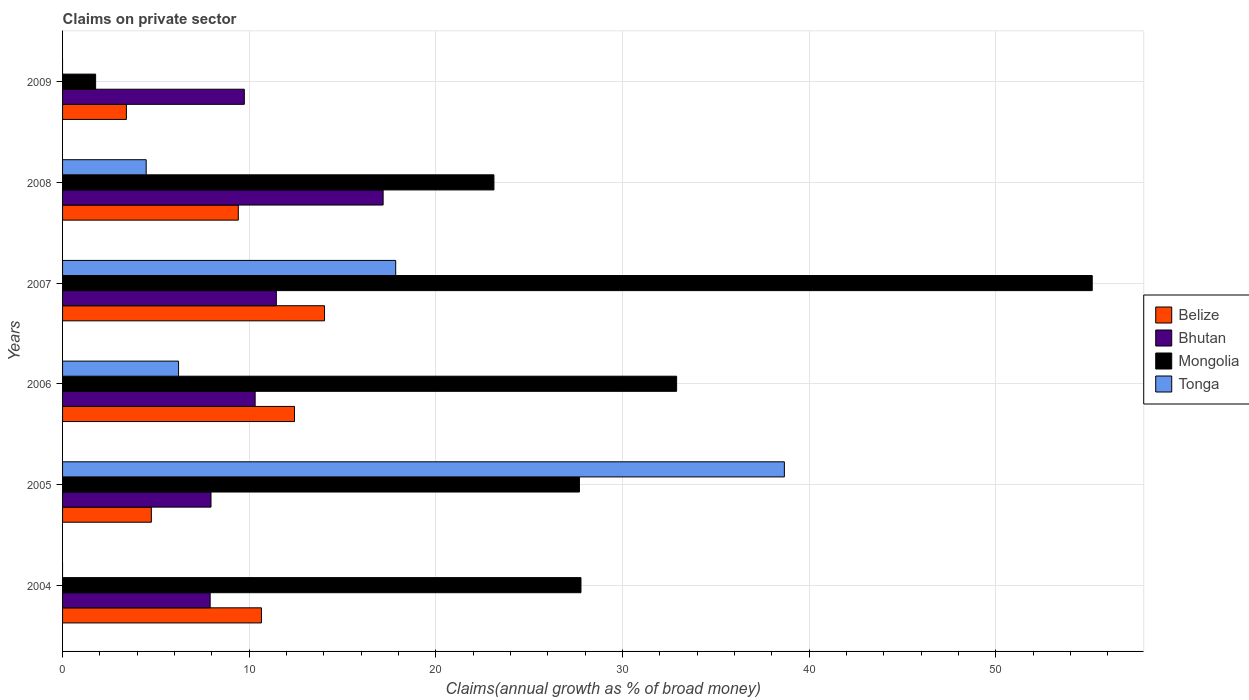How many groups of bars are there?
Offer a terse response. 6. Are the number of bars per tick equal to the number of legend labels?
Provide a short and direct response. No. Are the number of bars on each tick of the Y-axis equal?
Your answer should be compact. No. How many bars are there on the 6th tick from the top?
Your answer should be compact. 3. What is the percentage of broad money claimed on private sector in Tonga in 2008?
Offer a very short reply. 4.48. Across all years, what is the maximum percentage of broad money claimed on private sector in Belize?
Give a very brief answer. 14.04. Across all years, what is the minimum percentage of broad money claimed on private sector in Mongolia?
Make the answer very short. 1.77. In which year was the percentage of broad money claimed on private sector in Bhutan maximum?
Provide a succinct answer. 2008. What is the total percentage of broad money claimed on private sector in Tonga in the graph?
Your answer should be compact. 67.22. What is the difference between the percentage of broad money claimed on private sector in Belize in 2005 and that in 2009?
Make the answer very short. 1.34. What is the difference between the percentage of broad money claimed on private sector in Bhutan in 2009 and the percentage of broad money claimed on private sector in Tonga in 2007?
Give a very brief answer. -8.11. What is the average percentage of broad money claimed on private sector in Belize per year?
Your answer should be very brief. 9.12. In the year 2005, what is the difference between the percentage of broad money claimed on private sector in Mongolia and percentage of broad money claimed on private sector in Bhutan?
Keep it short and to the point. 19.74. What is the ratio of the percentage of broad money claimed on private sector in Bhutan in 2007 to that in 2008?
Your answer should be compact. 0.67. What is the difference between the highest and the second highest percentage of broad money claimed on private sector in Belize?
Your answer should be compact. 1.61. What is the difference between the highest and the lowest percentage of broad money claimed on private sector in Mongolia?
Provide a succinct answer. 53.4. Is the sum of the percentage of broad money claimed on private sector in Mongolia in 2006 and 2009 greater than the maximum percentage of broad money claimed on private sector in Belize across all years?
Offer a terse response. Yes. Are all the bars in the graph horizontal?
Your answer should be compact. Yes. What is the difference between two consecutive major ticks on the X-axis?
Ensure brevity in your answer.  10. Does the graph contain any zero values?
Your answer should be very brief. Yes. Does the graph contain grids?
Ensure brevity in your answer.  Yes. Where does the legend appear in the graph?
Offer a terse response. Center right. How many legend labels are there?
Your answer should be compact. 4. What is the title of the graph?
Your answer should be compact. Claims on private sector. What is the label or title of the X-axis?
Your answer should be very brief. Claims(annual growth as % of broad money). What is the label or title of the Y-axis?
Offer a terse response. Years. What is the Claims(annual growth as % of broad money) in Belize in 2004?
Keep it short and to the point. 10.66. What is the Claims(annual growth as % of broad money) in Bhutan in 2004?
Ensure brevity in your answer.  7.91. What is the Claims(annual growth as % of broad money) of Mongolia in 2004?
Provide a short and direct response. 27.78. What is the Claims(annual growth as % of broad money) of Belize in 2005?
Provide a short and direct response. 4.76. What is the Claims(annual growth as % of broad money) of Bhutan in 2005?
Offer a terse response. 7.95. What is the Claims(annual growth as % of broad money) in Mongolia in 2005?
Provide a succinct answer. 27.69. What is the Claims(annual growth as % of broad money) in Tonga in 2005?
Your answer should be very brief. 38.67. What is the Claims(annual growth as % of broad money) in Belize in 2006?
Your response must be concise. 12.43. What is the Claims(annual growth as % of broad money) of Bhutan in 2006?
Offer a terse response. 10.32. What is the Claims(annual growth as % of broad money) in Mongolia in 2006?
Your answer should be very brief. 32.9. What is the Claims(annual growth as % of broad money) in Tonga in 2006?
Offer a terse response. 6.22. What is the Claims(annual growth as % of broad money) of Belize in 2007?
Make the answer very short. 14.04. What is the Claims(annual growth as % of broad money) of Bhutan in 2007?
Ensure brevity in your answer.  11.45. What is the Claims(annual growth as % of broad money) of Mongolia in 2007?
Offer a very short reply. 55.17. What is the Claims(annual growth as % of broad money) of Tonga in 2007?
Offer a terse response. 17.85. What is the Claims(annual growth as % of broad money) of Belize in 2008?
Your answer should be very brief. 9.42. What is the Claims(annual growth as % of broad money) in Bhutan in 2008?
Give a very brief answer. 17.18. What is the Claims(annual growth as % of broad money) of Mongolia in 2008?
Make the answer very short. 23.11. What is the Claims(annual growth as % of broad money) in Tonga in 2008?
Your answer should be compact. 4.48. What is the Claims(annual growth as % of broad money) in Belize in 2009?
Provide a succinct answer. 3.42. What is the Claims(annual growth as % of broad money) of Bhutan in 2009?
Give a very brief answer. 9.74. What is the Claims(annual growth as % of broad money) of Mongolia in 2009?
Offer a terse response. 1.77. Across all years, what is the maximum Claims(annual growth as % of broad money) of Belize?
Ensure brevity in your answer.  14.04. Across all years, what is the maximum Claims(annual growth as % of broad money) of Bhutan?
Offer a terse response. 17.18. Across all years, what is the maximum Claims(annual growth as % of broad money) in Mongolia?
Provide a succinct answer. 55.17. Across all years, what is the maximum Claims(annual growth as % of broad money) of Tonga?
Your answer should be very brief. 38.67. Across all years, what is the minimum Claims(annual growth as % of broad money) in Belize?
Give a very brief answer. 3.42. Across all years, what is the minimum Claims(annual growth as % of broad money) in Bhutan?
Your answer should be very brief. 7.91. Across all years, what is the minimum Claims(annual growth as % of broad money) of Mongolia?
Your response must be concise. 1.77. Across all years, what is the minimum Claims(annual growth as % of broad money) of Tonga?
Give a very brief answer. 0. What is the total Claims(annual growth as % of broad money) of Belize in the graph?
Provide a short and direct response. 54.71. What is the total Claims(annual growth as % of broad money) of Bhutan in the graph?
Give a very brief answer. 64.55. What is the total Claims(annual growth as % of broad money) in Mongolia in the graph?
Provide a short and direct response. 168.43. What is the total Claims(annual growth as % of broad money) in Tonga in the graph?
Ensure brevity in your answer.  67.22. What is the difference between the Claims(annual growth as % of broad money) in Belize in 2004 and that in 2005?
Provide a short and direct response. 5.9. What is the difference between the Claims(annual growth as % of broad money) of Bhutan in 2004 and that in 2005?
Offer a very short reply. -0.05. What is the difference between the Claims(annual growth as % of broad money) of Mongolia in 2004 and that in 2005?
Give a very brief answer. 0.08. What is the difference between the Claims(annual growth as % of broad money) in Belize in 2004 and that in 2006?
Ensure brevity in your answer.  -1.77. What is the difference between the Claims(annual growth as % of broad money) in Bhutan in 2004 and that in 2006?
Your response must be concise. -2.41. What is the difference between the Claims(annual growth as % of broad money) in Mongolia in 2004 and that in 2006?
Make the answer very short. -5.13. What is the difference between the Claims(annual growth as % of broad money) of Belize in 2004 and that in 2007?
Your answer should be compact. -3.38. What is the difference between the Claims(annual growth as % of broad money) of Bhutan in 2004 and that in 2007?
Offer a very short reply. -3.55. What is the difference between the Claims(annual growth as % of broad money) in Mongolia in 2004 and that in 2007?
Give a very brief answer. -27.39. What is the difference between the Claims(annual growth as % of broad money) of Belize in 2004 and that in 2008?
Provide a succinct answer. 1.24. What is the difference between the Claims(annual growth as % of broad money) in Bhutan in 2004 and that in 2008?
Ensure brevity in your answer.  -9.27. What is the difference between the Claims(annual growth as % of broad money) of Mongolia in 2004 and that in 2008?
Keep it short and to the point. 4.66. What is the difference between the Claims(annual growth as % of broad money) in Belize in 2004 and that in 2009?
Provide a short and direct response. 7.24. What is the difference between the Claims(annual growth as % of broad money) in Bhutan in 2004 and that in 2009?
Your answer should be compact. -1.83. What is the difference between the Claims(annual growth as % of broad money) of Mongolia in 2004 and that in 2009?
Your answer should be very brief. 26. What is the difference between the Claims(annual growth as % of broad money) in Belize in 2005 and that in 2006?
Your response must be concise. -7.67. What is the difference between the Claims(annual growth as % of broad money) of Bhutan in 2005 and that in 2006?
Provide a succinct answer. -2.36. What is the difference between the Claims(annual growth as % of broad money) in Mongolia in 2005 and that in 2006?
Your response must be concise. -5.21. What is the difference between the Claims(annual growth as % of broad money) in Tonga in 2005 and that in 2006?
Ensure brevity in your answer.  32.46. What is the difference between the Claims(annual growth as % of broad money) of Belize in 2005 and that in 2007?
Ensure brevity in your answer.  -9.28. What is the difference between the Claims(annual growth as % of broad money) in Bhutan in 2005 and that in 2007?
Provide a succinct answer. -3.5. What is the difference between the Claims(annual growth as % of broad money) of Mongolia in 2005 and that in 2007?
Your response must be concise. -27.48. What is the difference between the Claims(annual growth as % of broad money) of Tonga in 2005 and that in 2007?
Ensure brevity in your answer.  20.83. What is the difference between the Claims(annual growth as % of broad money) of Belize in 2005 and that in 2008?
Offer a terse response. -4.66. What is the difference between the Claims(annual growth as % of broad money) of Bhutan in 2005 and that in 2008?
Make the answer very short. -9.22. What is the difference between the Claims(annual growth as % of broad money) in Mongolia in 2005 and that in 2008?
Provide a short and direct response. 4.58. What is the difference between the Claims(annual growth as % of broad money) of Tonga in 2005 and that in 2008?
Offer a terse response. 34.19. What is the difference between the Claims(annual growth as % of broad money) of Belize in 2005 and that in 2009?
Offer a terse response. 1.34. What is the difference between the Claims(annual growth as % of broad money) of Bhutan in 2005 and that in 2009?
Provide a short and direct response. -1.78. What is the difference between the Claims(annual growth as % of broad money) in Mongolia in 2005 and that in 2009?
Your answer should be very brief. 25.92. What is the difference between the Claims(annual growth as % of broad money) of Belize in 2006 and that in 2007?
Provide a short and direct response. -1.61. What is the difference between the Claims(annual growth as % of broad money) in Bhutan in 2006 and that in 2007?
Ensure brevity in your answer.  -1.14. What is the difference between the Claims(annual growth as % of broad money) in Mongolia in 2006 and that in 2007?
Ensure brevity in your answer.  -22.27. What is the difference between the Claims(annual growth as % of broad money) in Tonga in 2006 and that in 2007?
Offer a very short reply. -11.63. What is the difference between the Claims(annual growth as % of broad money) in Belize in 2006 and that in 2008?
Your response must be concise. 3.01. What is the difference between the Claims(annual growth as % of broad money) in Bhutan in 2006 and that in 2008?
Your answer should be very brief. -6.86. What is the difference between the Claims(annual growth as % of broad money) in Mongolia in 2006 and that in 2008?
Keep it short and to the point. 9.79. What is the difference between the Claims(annual growth as % of broad money) in Tonga in 2006 and that in 2008?
Provide a succinct answer. 1.73. What is the difference between the Claims(annual growth as % of broad money) of Belize in 2006 and that in 2009?
Your response must be concise. 9.01. What is the difference between the Claims(annual growth as % of broad money) of Bhutan in 2006 and that in 2009?
Provide a succinct answer. 0.58. What is the difference between the Claims(annual growth as % of broad money) of Mongolia in 2006 and that in 2009?
Provide a succinct answer. 31.13. What is the difference between the Claims(annual growth as % of broad money) of Belize in 2007 and that in 2008?
Your response must be concise. 4.62. What is the difference between the Claims(annual growth as % of broad money) in Bhutan in 2007 and that in 2008?
Ensure brevity in your answer.  -5.72. What is the difference between the Claims(annual growth as % of broad money) in Mongolia in 2007 and that in 2008?
Give a very brief answer. 32.06. What is the difference between the Claims(annual growth as % of broad money) in Tonga in 2007 and that in 2008?
Your response must be concise. 13.37. What is the difference between the Claims(annual growth as % of broad money) of Belize in 2007 and that in 2009?
Provide a short and direct response. 10.62. What is the difference between the Claims(annual growth as % of broad money) in Bhutan in 2007 and that in 2009?
Your response must be concise. 1.72. What is the difference between the Claims(annual growth as % of broad money) of Mongolia in 2007 and that in 2009?
Ensure brevity in your answer.  53.4. What is the difference between the Claims(annual growth as % of broad money) of Belize in 2008 and that in 2009?
Your answer should be compact. 6. What is the difference between the Claims(annual growth as % of broad money) of Bhutan in 2008 and that in 2009?
Offer a terse response. 7.44. What is the difference between the Claims(annual growth as % of broad money) of Mongolia in 2008 and that in 2009?
Your response must be concise. 21.34. What is the difference between the Claims(annual growth as % of broad money) of Belize in 2004 and the Claims(annual growth as % of broad money) of Bhutan in 2005?
Ensure brevity in your answer.  2.7. What is the difference between the Claims(annual growth as % of broad money) in Belize in 2004 and the Claims(annual growth as % of broad money) in Mongolia in 2005?
Keep it short and to the point. -17.04. What is the difference between the Claims(annual growth as % of broad money) in Belize in 2004 and the Claims(annual growth as % of broad money) in Tonga in 2005?
Ensure brevity in your answer.  -28.02. What is the difference between the Claims(annual growth as % of broad money) in Bhutan in 2004 and the Claims(annual growth as % of broad money) in Mongolia in 2005?
Offer a terse response. -19.79. What is the difference between the Claims(annual growth as % of broad money) of Bhutan in 2004 and the Claims(annual growth as % of broad money) of Tonga in 2005?
Provide a short and direct response. -30.77. What is the difference between the Claims(annual growth as % of broad money) of Mongolia in 2004 and the Claims(annual growth as % of broad money) of Tonga in 2005?
Provide a succinct answer. -10.9. What is the difference between the Claims(annual growth as % of broad money) of Belize in 2004 and the Claims(annual growth as % of broad money) of Bhutan in 2006?
Your response must be concise. 0.34. What is the difference between the Claims(annual growth as % of broad money) in Belize in 2004 and the Claims(annual growth as % of broad money) in Mongolia in 2006?
Offer a very short reply. -22.25. What is the difference between the Claims(annual growth as % of broad money) of Belize in 2004 and the Claims(annual growth as % of broad money) of Tonga in 2006?
Give a very brief answer. 4.44. What is the difference between the Claims(annual growth as % of broad money) in Bhutan in 2004 and the Claims(annual growth as % of broad money) in Mongolia in 2006?
Make the answer very short. -24.99. What is the difference between the Claims(annual growth as % of broad money) in Bhutan in 2004 and the Claims(annual growth as % of broad money) in Tonga in 2006?
Make the answer very short. 1.69. What is the difference between the Claims(annual growth as % of broad money) of Mongolia in 2004 and the Claims(annual growth as % of broad money) of Tonga in 2006?
Provide a succinct answer. 21.56. What is the difference between the Claims(annual growth as % of broad money) of Belize in 2004 and the Claims(annual growth as % of broad money) of Bhutan in 2007?
Make the answer very short. -0.8. What is the difference between the Claims(annual growth as % of broad money) in Belize in 2004 and the Claims(annual growth as % of broad money) in Mongolia in 2007?
Offer a very short reply. -44.51. What is the difference between the Claims(annual growth as % of broad money) of Belize in 2004 and the Claims(annual growth as % of broad money) of Tonga in 2007?
Provide a succinct answer. -7.19. What is the difference between the Claims(annual growth as % of broad money) in Bhutan in 2004 and the Claims(annual growth as % of broad money) in Mongolia in 2007?
Keep it short and to the point. -47.26. What is the difference between the Claims(annual growth as % of broad money) in Bhutan in 2004 and the Claims(annual growth as % of broad money) in Tonga in 2007?
Ensure brevity in your answer.  -9.94. What is the difference between the Claims(annual growth as % of broad money) in Mongolia in 2004 and the Claims(annual growth as % of broad money) in Tonga in 2007?
Your response must be concise. 9.93. What is the difference between the Claims(annual growth as % of broad money) in Belize in 2004 and the Claims(annual growth as % of broad money) in Bhutan in 2008?
Provide a short and direct response. -6.52. What is the difference between the Claims(annual growth as % of broad money) in Belize in 2004 and the Claims(annual growth as % of broad money) in Mongolia in 2008?
Make the answer very short. -12.46. What is the difference between the Claims(annual growth as % of broad money) in Belize in 2004 and the Claims(annual growth as % of broad money) in Tonga in 2008?
Offer a terse response. 6.18. What is the difference between the Claims(annual growth as % of broad money) in Bhutan in 2004 and the Claims(annual growth as % of broad money) in Mongolia in 2008?
Provide a succinct answer. -15.2. What is the difference between the Claims(annual growth as % of broad money) in Bhutan in 2004 and the Claims(annual growth as % of broad money) in Tonga in 2008?
Keep it short and to the point. 3.43. What is the difference between the Claims(annual growth as % of broad money) of Mongolia in 2004 and the Claims(annual growth as % of broad money) of Tonga in 2008?
Your response must be concise. 23.3. What is the difference between the Claims(annual growth as % of broad money) in Belize in 2004 and the Claims(annual growth as % of broad money) in Bhutan in 2009?
Make the answer very short. 0.92. What is the difference between the Claims(annual growth as % of broad money) in Belize in 2004 and the Claims(annual growth as % of broad money) in Mongolia in 2009?
Your answer should be very brief. 8.89. What is the difference between the Claims(annual growth as % of broad money) of Bhutan in 2004 and the Claims(annual growth as % of broad money) of Mongolia in 2009?
Give a very brief answer. 6.14. What is the difference between the Claims(annual growth as % of broad money) in Belize in 2005 and the Claims(annual growth as % of broad money) in Bhutan in 2006?
Your answer should be compact. -5.56. What is the difference between the Claims(annual growth as % of broad money) in Belize in 2005 and the Claims(annual growth as % of broad money) in Mongolia in 2006?
Keep it short and to the point. -28.15. What is the difference between the Claims(annual growth as % of broad money) of Belize in 2005 and the Claims(annual growth as % of broad money) of Tonga in 2006?
Keep it short and to the point. -1.46. What is the difference between the Claims(annual growth as % of broad money) in Bhutan in 2005 and the Claims(annual growth as % of broad money) in Mongolia in 2006?
Give a very brief answer. -24.95. What is the difference between the Claims(annual growth as % of broad money) in Bhutan in 2005 and the Claims(annual growth as % of broad money) in Tonga in 2006?
Provide a short and direct response. 1.74. What is the difference between the Claims(annual growth as % of broad money) in Mongolia in 2005 and the Claims(annual growth as % of broad money) in Tonga in 2006?
Ensure brevity in your answer.  21.48. What is the difference between the Claims(annual growth as % of broad money) of Belize in 2005 and the Claims(annual growth as % of broad money) of Bhutan in 2007?
Your answer should be very brief. -6.7. What is the difference between the Claims(annual growth as % of broad money) of Belize in 2005 and the Claims(annual growth as % of broad money) of Mongolia in 2007?
Your answer should be compact. -50.41. What is the difference between the Claims(annual growth as % of broad money) in Belize in 2005 and the Claims(annual growth as % of broad money) in Tonga in 2007?
Provide a short and direct response. -13.09. What is the difference between the Claims(annual growth as % of broad money) in Bhutan in 2005 and the Claims(annual growth as % of broad money) in Mongolia in 2007?
Keep it short and to the point. -47.22. What is the difference between the Claims(annual growth as % of broad money) of Bhutan in 2005 and the Claims(annual growth as % of broad money) of Tonga in 2007?
Ensure brevity in your answer.  -9.9. What is the difference between the Claims(annual growth as % of broad money) in Mongolia in 2005 and the Claims(annual growth as % of broad money) in Tonga in 2007?
Ensure brevity in your answer.  9.84. What is the difference between the Claims(annual growth as % of broad money) in Belize in 2005 and the Claims(annual growth as % of broad money) in Bhutan in 2008?
Provide a succinct answer. -12.42. What is the difference between the Claims(annual growth as % of broad money) of Belize in 2005 and the Claims(annual growth as % of broad money) of Mongolia in 2008?
Your answer should be compact. -18.36. What is the difference between the Claims(annual growth as % of broad money) of Belize in 2005 and the Claims(annual growth as % of broad money) of Tonga in 2008?
Make the answer very short. 0.28. What is the difference between the Claims(annual growth as % of broad money) in Bhutan in 2005 and the Claims(annual growth as % of broad money) in Mongolia in 2008?
Make the answer very short. -15.16. What is the difference between the Claims(annual growth as % of broad money) in Bhutan in 2005 and the Claims(annual growth as % of broad money) in Tonga in 2008?
Offer a terse response. 3.47. What is the difference between the Claims(annual growth as % of broad money) in Mongolia in 2005 and the Claims(annual growth as % of broad money) in Tonga in 2008?
Provide a succinct answer. 23.21. What is the difference between the Claims(annual growth as % of broad money) of Belize in 2005 and the Claims(annual growth as % of broad money) of Bhutan in 2009?
Make the answer very short. -4.98. What is the difference between the Claims(annual growth as % of broad money) of Belize in 2005 and the Claims(annual growth as % of broad money) of Mongolia in 2009?
Your response must be concise. 2.99. What is the difference between the Claims(annual growth as % of broad money) of Bhutan in 2005 and the Claims(annual growth as % of broad money) of Mongolia in 2009?
Give a very brief answer. 6.18. What is the difference between the Claims(annual growth as % of broad money) in Belize in 2006 and the Claims(annual growth as % of broad money) in Bhutan in 2007?
Make the answer very short. 0.97. What is the difference between the Claims(annual growth as % of broad money) in Belize in 2006 and the Claims(annual growth as % of broad money) in Mongolia in 2007?
Ensure brevity in your answer.  -42.74. What is the difference between the Claims(annual growth as % of broad money) of Belize in 2006 and the Claims(annual growth as % of broad money) of Tonga in 2007?
Ensure brevity in your answer.  -5.42. What is the difference between the Claims(annual growth as % of broad money) of Bhutan in 2006 and the Claims(annual growth as % of broad money) of Mongolia in 2007?
Your answer should be compact. -44.85. What is the difference between the Claims(annual growth as % of broad money) of Bhutan in 2006 and the Claims(annual growth as % of broad money) of Tonga in 2007?
Give a very brief answer. -7.53. What is the difference between the Claims(annual growth as % of broad money) in Mongolia in 2006 and the Claims(annual growth as % of broad money) in Tonga in 2007?
Give a very brief answer. 15.05. What is the difference between the Claims(annual growth as % of broad money) of Belize in 2006 and the Claims(annual growth as % of broad money) of Bhutan in 2008?
Your response must be concise. -4.75. What is the difference between the Claims(annual growth as % of broad money) in Belize in 2006 and the Claims(annual growth as % of broad money) in Mongolia in 2008?
Make the answer very short. -10.69. What is the difference between the Claims(annual growth as % of broad money) in Belize in 2006 and the Claims(annual growth as % of broad money) in Tonga in 2008?
Provide a short and direct response. 7.95. What is the difference between the Claims(annual growth as % of broad money) in Bhutan in 2006 and the Claims(annual growth as % of broad money) in Mongolia in 2008?
Make the answer very short. -12.79. What is the difference between the Claims(annual growth as % of broad money) of Bhutan in 2006 and the Claims(annual growth as % of broad money) of Tonga in 2008?
Provide a short and direct response. 5.84. What is the difference between the Claims(annual growth as % of broad money) in Mongolia in 2006 and the Claims(annual growth as % of broad money) in Tonga in 2008?
Give a very brief answer. 28.42. What is the difference between the Claims(annual growth as % of broad money) in Belize in 2006 and the Claims(annual growth as % of broad money) in Bhutan in 2009?
Ensure brevity in your answer.  2.69. What is the difference between the Claims(annual growth as % of broad money) of Belize in 2006 and the Claims(annual growth as % of broad money) of Mongolia in 2009?
Offer a very short reply. 10.66. What is the difference between the Claims(annual growth as % of broad money) in Bhutan in 2006 and the Claims(annual growth as % of broad money) in Mongolia in 2009?
Provide a succinct answer. 8.55. What is the difference between the Claims(annual growth as % of broad money) of Belize in 2007 and the Claims(annual growth as % of broad money) of Bhutan in 2008?
Give a very brief answer. -3.14. What is the difference between the Claims(annual growth as % of broad money) in Belize in 2007 and the Claims(annual growth as % of broad money) in Mongolia in 2008?
Offer a terse response. -9.08. What is the difference between the Claims(annual growth as % of broad money) in Belize in 2007 and the Claims(annual growth as % of broad money) in Tonga in 2008?
Offer a terse response. 9.56. What is the difference between the Claims(annual growth as % of broad money) of Bhutan in 2007 and the Claims(annual growth as % of broad money) of Mongolia in 2008?
Keep it short and to the point. -11.66. What is the difference between the Claims(annual growth as % of broad money) of Bhutan in 2007 and the Claims(annual growth as % of broad money) of Tonga in 2008?
Provide a short and direct response. 6.97. What is the difference between the Claims(annual growth as % of broad money) in Mongolia in 2007 and the Claims(annual growth as % of broad money) in Tonga in 2008?
Offer a terse response. 50.69. What is the difference between the Claims(annual growth as % of broad money) of Belize in 2007 and the Claims(annual growth as % of broad money) of Bhutan in 2009?
Provide a succinct answer. 4.3. What is the difference between the Claims(annual growth as % of broad money) of Belize in 2007 and the Claims(annual growth as % of broad money) of Mongolia in 2009?
Provide a short and direct response. 12.26. What is the difference between the Claims(annual growth as % of broad money) in Bhutan in 2007 and the Claims(annual growth as % of broad money) in Mongolia in 2009?
Provide a succinct answer. 9.68. What is the difference between the Claims(annual growth as % of broad money) in Belize in 2008 and the Claims(annual growth as % of broad money) in Bhutan in 2009?
Keep it short and to the point. -0.32. What is the difference between the Claims(annual growth as % of broad money) of Belize in 2008 and the Claims(annual growth as % of broad money) of Mongolia in 2009?
Offer a terse response. 7.65. What is the difference between the Claims(annual growth as % of broad money) in Bhutan in 2008 and the Claims(annual growth as % of broad money) in Mongolia in 2009?
Your response must be concise. 15.4. What is the average Claims(annual growth as % of broad money) of Belize per year?
Provide a short and direct response. 9.12. What is the average Claims(annual growth as % of broad money) of Bhutan per year?
Provide a short and direct response. 10.76. What is the average Claims(annual growth as % of broad money) in Mongolia per year?
Keep it short and to the point. 28.07. What is the average Claims(annual growth as % of broad money) in Tonga per year?
Your answer should be compact. 11.2. In the year 2004, what is the difference between the Claims(annual growth as % of broad money) in Belize and Claims(annual growth as % of broad money) in Bhutan?
Keep it short and to the point. 2.75. In the year 2004, what is the difference between the Claims(annual growth as % of broad money) in Belize and Claims(annual growth as % of broad money) in Mongolia?
Offer a terse response. -17.12. In the year 2004, what is the difference between the Claims(annual growth as % of broad money) of Bhutan and Claims(annual growth as % of broad money) of Mongolia?
Provide a short and direct response. -19.87. In the year 2005, what is the difference between the Claims(annual growth as % of broad money) in Belize and Claims(annual growth as % of broad money) in Bhutan?
Ensure brevity in your answer.  -3.2. In the year 2005, what is the difference between the Claims(annual growth as % of broad money) in Belize and Claims(annual growth as % of broad money) in Mongolia?
Your response must be concise. -22.94. In the year 2005, what is the difference between the Claims(annual growth as % of broad money) in Belize and Claims(annual growth as % of broad money) in Tonga?
Your answer should be very brief. -33.92. In the year 2005, what is the difference between the Claims(annual growth as % of broad money) in Bhutan and Claims(annual growth as % of broad money) in Mongolia?
Provide a short and direct response. -19.74. In the year 2005, what is the difference between the Claims(annual growth as % of broad money) of Bhutan and Claims(annual growth as % of broad money) of Tonga?
Ensure brevity in your answer.  -30.72. In the year 2005, what is the difference between the Claims(annual growth as % of broad money) of Mongolia and Claims(annual growth as % of broad money) of Tonga?
Provide a short and direct response. -10.98. In the year 2006, what is the difference between the Claims(annual growth as % of broad money) of Belize and Claims(annual growth as % of broad money) of Bhutan?
Provide a succinct answer. 2.11. In the year 2006, what is the difference between the Claims(annual growth as % of broad money) in Belize and Claims(annual growth as % of broad money) in Mongolia?
Offer a terse response. -20.48. In the year 2006, what is the difference between the Claims(annual growth as % of broad money) in Belize and Claims(annual growth as % of broad money) in Tonga?
Offer a terse response. 6.21. In the year 2006, what is the difference between the Claims(annual growth as % of broad money) of Bhutan and Claims(annual growth as % of broad money) of Mongolia?
Provide a succinct answer. -22.58. In the year 2006, what is the difference between the Claims(annual growth as % of broad money) of Bhutan and Claims(annual growth as % of broad money) of Tonga?
Your answer should be compact. 4.1. In the year 2006, what is the difference between the Claims(annual growth as % of broad money) of Mongolia and Claims(annual growth as % of broad money) of Tonga?
Offer a very short reply. 26.69. In the year 2007, what is the difference between the Claims(annual growth as % of broad money) in Belize and Claims(annual growth as % of broad money) in Bhutan?
Your response must be concise. 2.58. In the year 2007, what is the difference between the Claims(annual growth as % of broad money) of Belize and Claims(annual growth as % of broad money) of Mongolia?
Your answer should be compact. -41.13. In the year 2007, what is the difference between the Claims(annual growth as % of broad money) of Belize and Claims(annual growth as % of broad money) of Tonga?
Keep it short and to the point. -3.81. In the year 2007, what is the difference between the Claims(annual growth as % of broad money) in Bhutan and Claims(annual growth as % of broad money) in Mongolia?
Offer a terse response. -43.72. In the year 2007, what is the difference between the Claims(annual growth as % of broad money) in Bhutan and Claims(annual growth as % of broad money) in Tonga?
Give a very brief answer. -6.4. In the year 2007, what is the difference between the Claims(annual growth as % of broad money) in Mongolia and Claims(annual growth as % of broad money) in Tonga?
Your answer should be compact. 37.32. In the year 2008, what is the difference between the Claims(annual growth as % of broad money) in Belize and Claims(annual growth as % of broad money) in Bhutan?
Your response must be concise. -7.76. In the year 2008, what is the difference between the Claims(annual growth as % of broad money) of Belize and Claims(annual growth as % of broad money) of Mongolia?
Provide a succinct answer. -13.7. In the year 2008, what is the difference between the Claims(annual growth as % of broad money) in Belize and Claims(annual growth as % of broad money) in Tonga?
Your answer should be very brief. 4.94. In the year 2008, what is the difference between the Claims(annual growth as % of broad money) of Bhutan and Claims(annual growth as % of broad money) of Mongolia?
Provide a succinct answer. -5.94. In the year 2008, what is the difference between the Claims(annual growth as % of broad money) in Bhutan and Claims(annual growth as % of broad money) in Tonga?
Offer a very short reply. 12.7. In the year 2008, what is the difference between the Claims(annual growth as % of broad money) of Mongolia and Claims(annual growth as % of broad money) of Tonga?
Provide a short and direct response. 18.63. In the year 2009, what is the difference between the Claims(annual growth as % of broad money) in Belize and Claims(annual growth as % of broad money) in Bhutan?
Keep it short and to the point. -6.32. In the year 2009, what is the difference between the Claims(annual growth as % of broad money) of Belize and Claims(annual growth as % of broad money) of Mongolia?
Provide a succinct answer. 1.65. In the year 2009, what is the difference between the Claims(annual growth as % of broad money) in Bhutan and Claims(annual growth as % of broad money) in Mongolia?
Offer a terse response. 7.97. What is the ratio of the Claims(annual growth as % of broad money) of Belize in 2004 to that in 2005?
Offer a terse response. 2.24. What is the ratio of the Claims(annual growth as % of broad money) of Mongolia in 2004 to that in 2005?
Your response must be concise. 1. What is the ratio of the Claims(annual growth as % of broad money) in Belize in 2004 to that in 2006?
Your response must be concise. 0.86. What is the ratio of the Claims(annual growth as % of broad money) of Bhutan in 2004 to that in 2006?
Provide a short and direct response. 0.77. What is the ratio of the Claims(annual growth as % of broad money) in Mongolia in 2004 to that in 2006?
Give a very brief answer. 0.84. What is the ratio of the Claims(annual growth as % of broad money) in Belize in 2004 to that in 2007?
Make the answer very short. 0.76. What is the ratio of the Claims(annual growth as % of broad money) of Bhutan in 2004 to that in 2007?
Offer a terse response. 0.69. What is the ratio of the Claims(annual growth as % of broad money) of Mongolia in 2004 to that in 2007?
Keep it short and to the point. 0.5. What is the ratio of the Claims(annual growth as % of broad money) in Belize in 2004 to that in 2008?
Give a very brief answer. 1.13. What is the ratio of the Claims(annual growth as % of broad money) of Bhutan in 2004 to that in 2008?
Your answer should be compact. 0.46. What is the ratio of the Claims(annual growth as % of broad money) of Mongolia in 2004 to that in 2008?
Make the answer very short. 1.2. What is the ratio of the Claims(annual growth as % of broad money) of Belize in 2004 to that in 2009?
Make the answer very short. 3.12. What is the ratio of the Claims(annual growth as % of broad money) of Bhutan in 2004 to that in 2009?
Offer a terse response. 0.81. What is the ratio of the Claims(annual growth as % of broad money) of Mongolia in 2004 to that in 2009?
Provide a short and direct response. 15.68. What is the ratio of the Claims(annual growth as % of broad money) of Belize in 2005 to that in 2006?
Provide a short and direct response. 0.38. What is the ratio of the Claims(annual growth as % of broad money) in Bhutan in 2005 to that in 2006?
Keep it short and to the point. 0.77. What is the ratio of the Claims(annual growth as % of broad money) in Mongolia in 2005 to that in 2006?
Your answer should be very brief. 0.84. What is the ratio of the Claims(annual growth as % of broad money) of Tonga in 2005 to that in 2006?
Provide a succinct answer. 6.22. What is the ratio of the Claims(annual growth as % of broad money) in Belize in 2005 to that in 2007?
Give a very brief answer. 0.34. What is the ratio of the Claims(annual growth as % of broad money) in Bhutan in 2005 to that in 2007?
Provide a succinct answer. 0.69. What is the ratio of the Claims(annual growth as % of broad money) in Mongolia in 2005 to that in 2007?
Offer a very short reply. 0.5. What is the ratio of the Claims(annual growth as % of broad money) of Tonga in 2005 to that in 2007?
Offer a terse response. 2.17. What is the ratio of the Claims(annual growth as % of broad money) in Belize in 2005 to that in 2008?
Make the answer very short. 0.51. What is the ratio of the Claims(annual growth as % of broad money) of Bhutan in 2005 to that in 2008?
Provide a short and direct response. 0.46. What is the ratio of the Claims(annual growth as % of broad money) of Mongolia in 2005 to that in 2008?
Your response must be concise. 1.2. What is the ratio of the Claims(annual growth as % of broad money) in Tonga in 2005 to that in 2008?
Your answer should be very brief. 8.63. What is the ratio of the Claims(annual growth as % of broad money) of Belize in 2005 to that in 2009?
Your response must be concise. 1.39. What is the ratio of the Claims(annual growth as % of broad money) of Bhutan in 2005 to that in 2009?
Make the answer very short. 0.82. What is the ratio of the Claims(annual growth as % of broad money) in Mongolia in 2005 to that in 2009?
Offer a terse response. 15.64. What is the ratio of the Claims(annual growth as % of broad money) of Belize in 2006 to that in 2007?
Ensure brevity in your answer.  0.89. What is the ratio of the Claims(annual growth as % of broad money) of Bhutan in 2006 to that in 2007?
Keep it short and to the point. 0.9. What is the ratio of the Claims(annual growth as % of broad money) of Mongolia in 2006 to that in 2007?
Your response must be concise. 0.6. What is the ratio of the Claims(annual growth as % of broad money) in Tonga in 2006 to that in 2007?
Ensure brevity in your answer.  0.35. What is the ratio of the Claims(annual growth as % of broad money) in Belize in 2006 to that in 2008?
Your answer should be compact. 1.32. What is the ratio of the Claims(annual growth as % of broad money) in Bhutan in 2006 to that in 2008?
Offer a very short reply. 0.6. What is the ratio of the Claims(annual growth as % of broad money) of Mongolia in 2006 to that in 2008?
Your answer should be compact. 1.42. What is the ratio of the Claims(annual growth as % of broad money) of Tonga in 2006 to that in 2008?
Offer a very short reply. 1.39. What is the ratio of the Claims(annual growth as % of broad money) in Belize in 2006 to that in 2009?
Offer a terse response. 3.63. What is the ratio of the Claims(annual growth as % of broad money) of Bhutan in 2006 to that in 2009?
Your answer should be very brief. 1.06. What is the ratio of the Claims(annual growth as % of broad money) of Mongolia in 2006 to that in 2009?
Provide a succinct answer. 18.58. What is the ratio of the Claims(annual growth as % of broad money) in Belize in 2007 to that in 2008?
Provide a succinct answer. 1.49. What is the ratio of the Claims(annual growth as % of broad money) in Bhutan in 2007 to that in 2008?
Ensure brevity in your answer.  0.67. What is the ratio of the Claims(annual growth as % of broad money) in Mongolia in 2007 to that in 2008?
Your response must be concise. 2.39. What is the ratio of the Claims(annual growth as % of broad money) in Tonga in 2007 to that in 2008?
Your answer should be very brief. 3.98. What is the ratio of the Claims(annual growth as % of broad money) in Belize in 2007 to that in 2009?
Offer a very short reply. 4.1. What is the ratio of the Claims(annual growth as % of broad money) in Bhutan in 2007 to that in 2009?
Keep it short and to the point. 1.18. What is the ratio of the Claims(annual growth as % of broad money) in Mongolia in 2007 to that in 2009?
Give a very brief answer. 31.15. What is the ratio of the Claims(annual growth as % of broad money) of Belize in 2008 to that in 2009?
Provide a short and direct response. 2.75. What is the ratio of the Claims(annual growth as % of broad money) in Bhutan in 2008 to that in 2009?
Offer a terse response. 1.76. What is the ratio of the Claims(annual growth as % of broad money) in Mongolia in 2008 to that in 2009?
Give a very brief answer. 13.05. What is the difference between the highest and the second highest Claims(annual growth as % of broad money) of Belize?
Provide a succinct answer. 1.61. What is the difference between the highest and the second highest Claims(annual growth as % of broad money) in Bhutan?
Keep it short and to the point. 5.72. What is the difference between the highest and the second highest Claims(annual growth as % of broad money) of Mongolia?
Provide a short and direct response. 22.27. What is the difference between the highest and the second highest Claims(annual growth as % of broad money) in Tonga?
Provide a short and direct response. 20.83. What is the difference between the highest and the lowest Claims(annual growth as % of broad money) of Belize?
Provide a short and direct response. 10.62. What is the difference between the highest and the lowest Claims(annual growth as % of broad money) in Bhutan?
Your answer should be very brief. 9.27. What is the difference between the highest and the lowest Claims(annual growth as % of broad money) of Mongolia?
Ensure brevity in your answer.  53.4. What is the difference between the highest and the lowest Claims(annual growth as % of broad money) of Tonga?
Offer a very short reply. 38.67. 